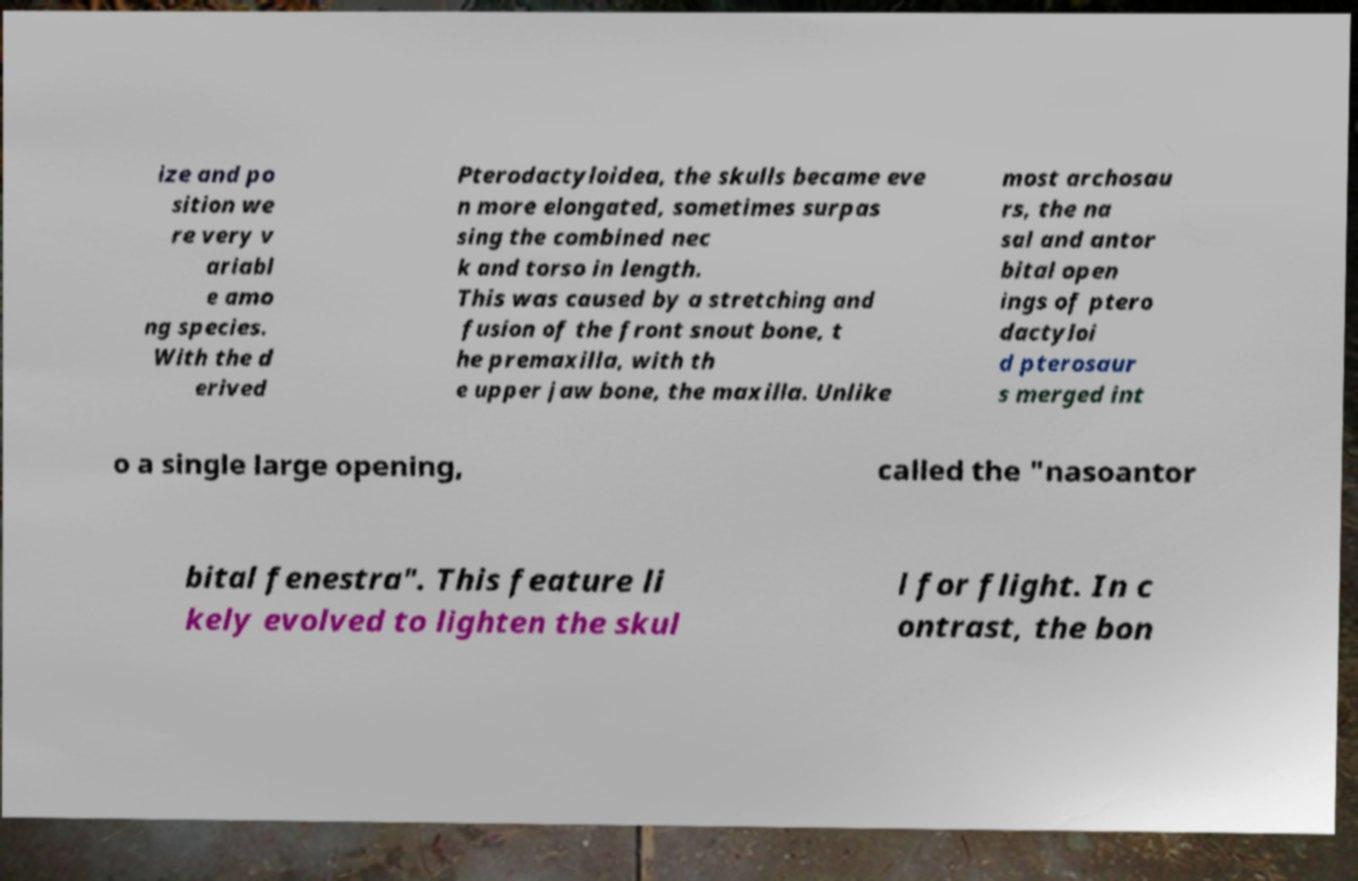Please read and relay the text visible in this image. What does it say? ize and po sition we re very v ariabl e amo ng species. With the d erived Pterodactyloidea, the skulls became eve n more elongated, sometimes surpas sing the combined nec k and torso in length. This was caused by a stretching and fusion of the front snout bone, t he premaxilla, with th e upper jaw bone, the maxilla. Unlike most archosau rs, the na sal and antor bital open ings of ptero dactyloi d pterosaur s merged int o a single large opening, called the "nasoantor bital fenestra". This feature li kely evolved to lighten the skul l for flight. In c ontrast, the bon 